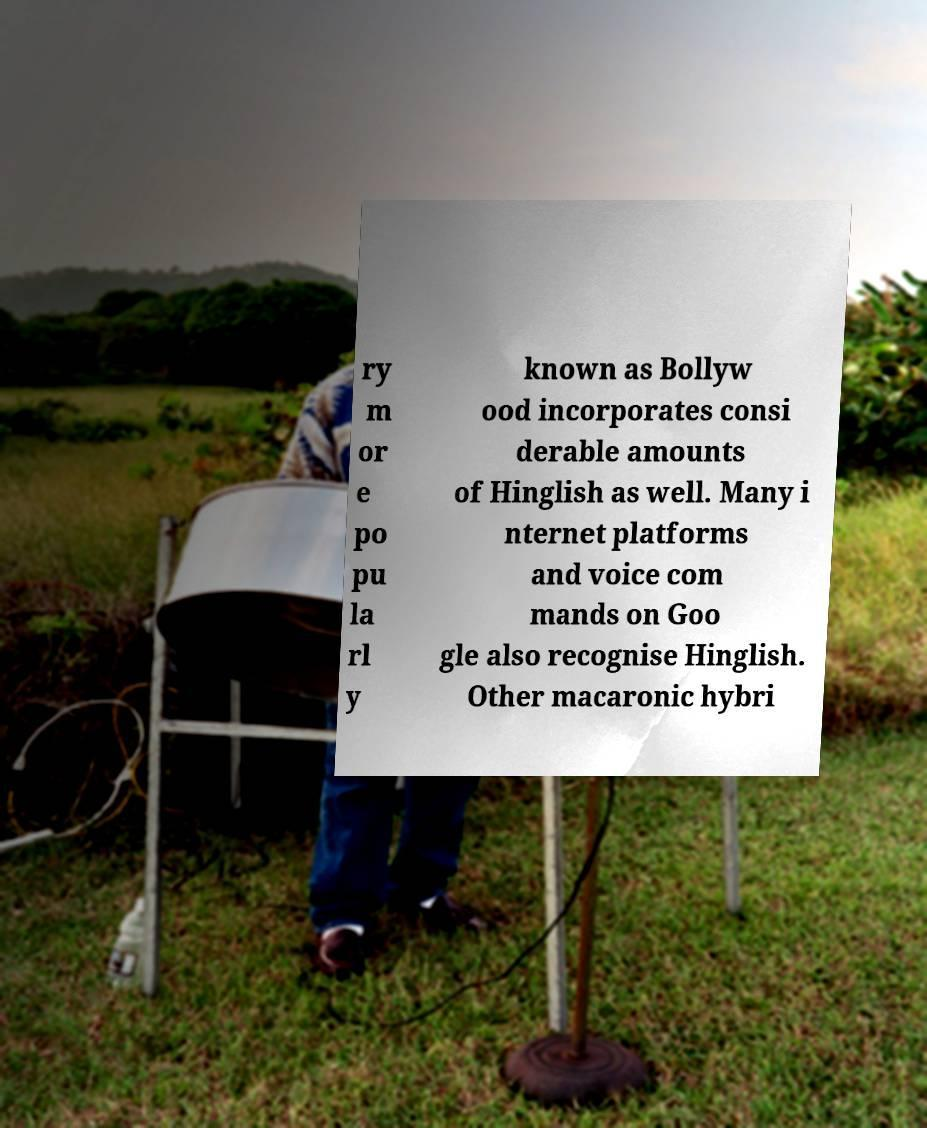I need the written content from this picture converted into text. Can you do that? ry m or e po pu la rl y known as Bollyw ood incorporates consi derable amounts of Hinglish as well. Many i nternet platforms and voice com mands on Goo gle also recognise Hinglish. Other macaronic hybri 